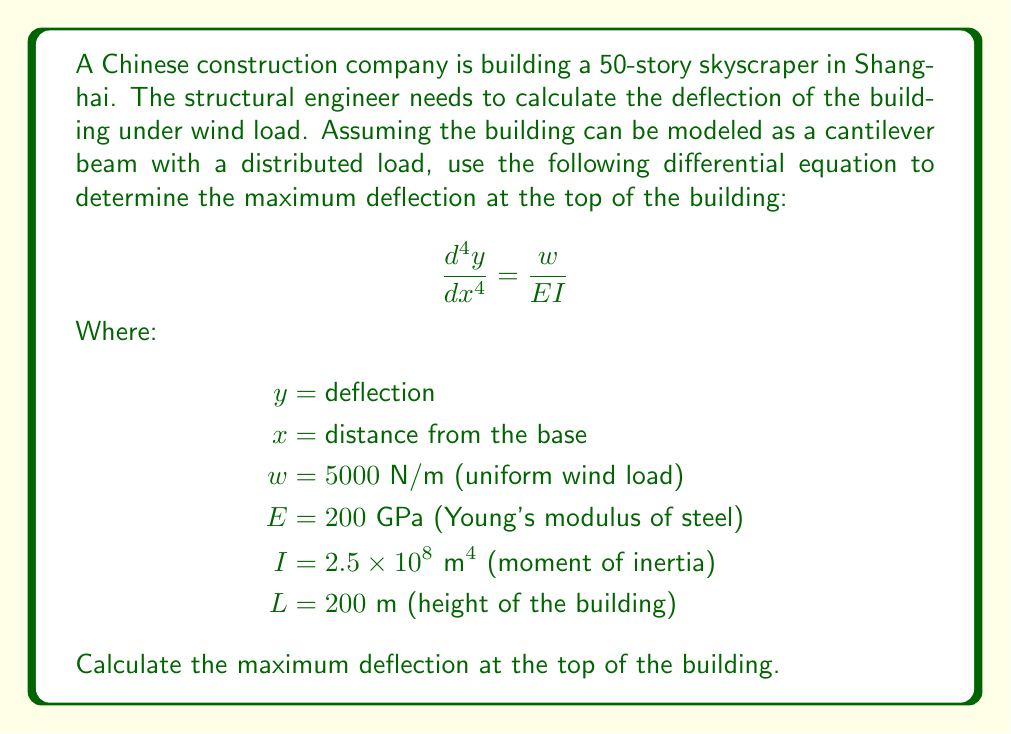Give your solution to this math problem. To solve this problem, we need to integrate the differential equation four times:

1. Integrate once:
   $$\frac{d^3y}{dx^3} = \frac{wx}{EI} + C_1$$

2. Integrate again:
   $$\frac{d^2y}{dx^2} = \frac{wx^2}{2EI} + C_1x + C_2$$

3. Integrate a third time:
   $$\frac{dy}{dx} = \frac{wx^3}{6EI} + \frac{C_1x^2}{2} + C_2x + C_3$$

4. Integrate a fourth time:
   $$y = \frac{wx^4}{24EI} + \frac{C_1x^3}{6} + \frac{C_2x^2}{2} + C_3x + C_4$$

Now we need to apply boundary conditions:

1. At x = 0 (base), y = 0:
   $$0 = C_4$$

2. At x = 0 (base), dy/dx = 0:
   $$0 = C_3$$

3. At x = L (top), d^2y/dx^2 = 0 (no bending moment):
   $$0 = \frac{wL^2}{2EI} + C_1L + C_2$$

4. At x = L (top), d^3y/dx^3 = 0 (no shear force):
   $$0 = \frac{wL}{EI} + C_1$$

From the last condition:
$$C_1 = -\frac{wL}{EI}$$

Substituting this into the third condition:
$$C_2 = \frac{wL^2}{2EI}$$

Now we can substitute all constants into the equation for y:

$$y = \frac{wx^4}{24EI} - \frac{wLx^3}{6EI} + \frac{wL^2x^2}{4EI}$$

To find the maximum deflection, we evaluate this at x = L:

$$y_{max} = \frac{wL^4}{8EI}$$

Substituting the given values:

$$y_{max} = \frac{5000 \times 200^4}{8 \times 200 \times 10^9 \times 2.5 \times 10^8} = 0.2 \text{ m}$$
Answer: 0.2 m 